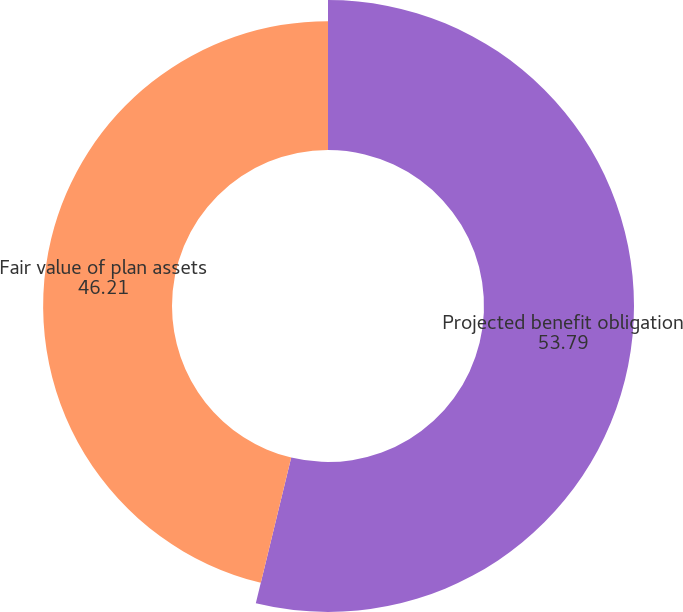<chart> <loc_0><loc_0><loc_500><loc_500><pie_chart><fcel>Projected benefit obligation<fcel>Fair value of plan assets<nl><fcel>53.79%<fcel>46.21%<nl></chart> 